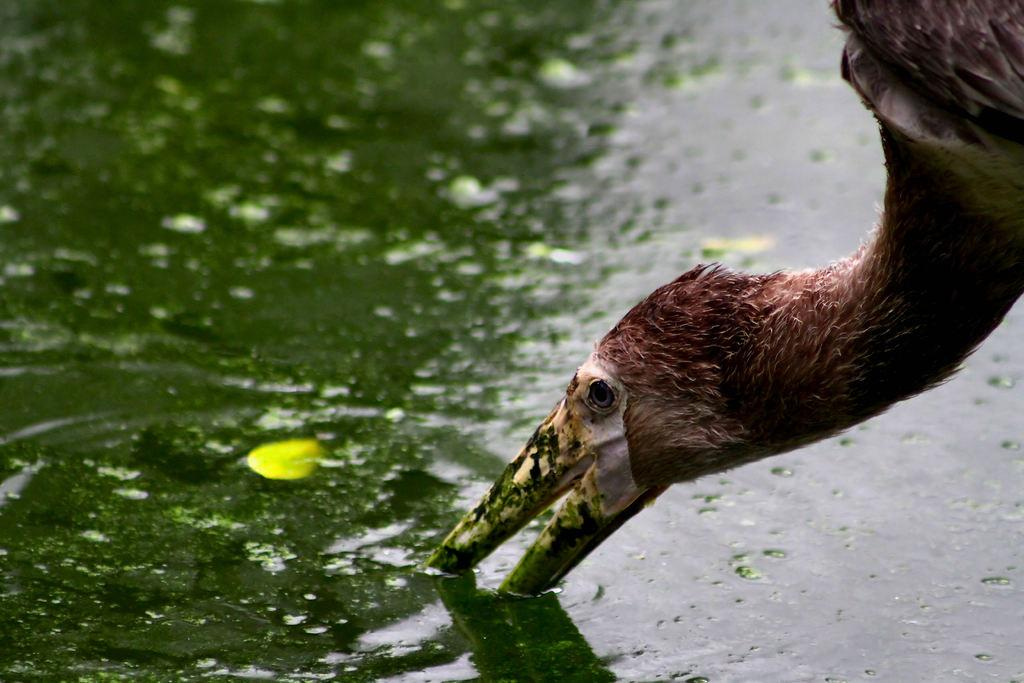What type of animal can be seen in the image? There is a bird in the image. What is present in the water in the image? There is algae in the image. What is the primary element visible in the image? There is water visible in the image. What type of verse is being recited by the bird in the image? There is no indication in the image that the bird is reciting any verse, as birds do not have the ability to recite poetry. 